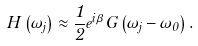<formula> <loc_0><loc_0><loc_500><loc_500>H \left ( \omega _ { j } \right ) \approx \frac { 1 } { 2 } e ^ { i \beta } G \left ( \omega _ { j } - \omega _ { 0 } \right ) .</formula> 